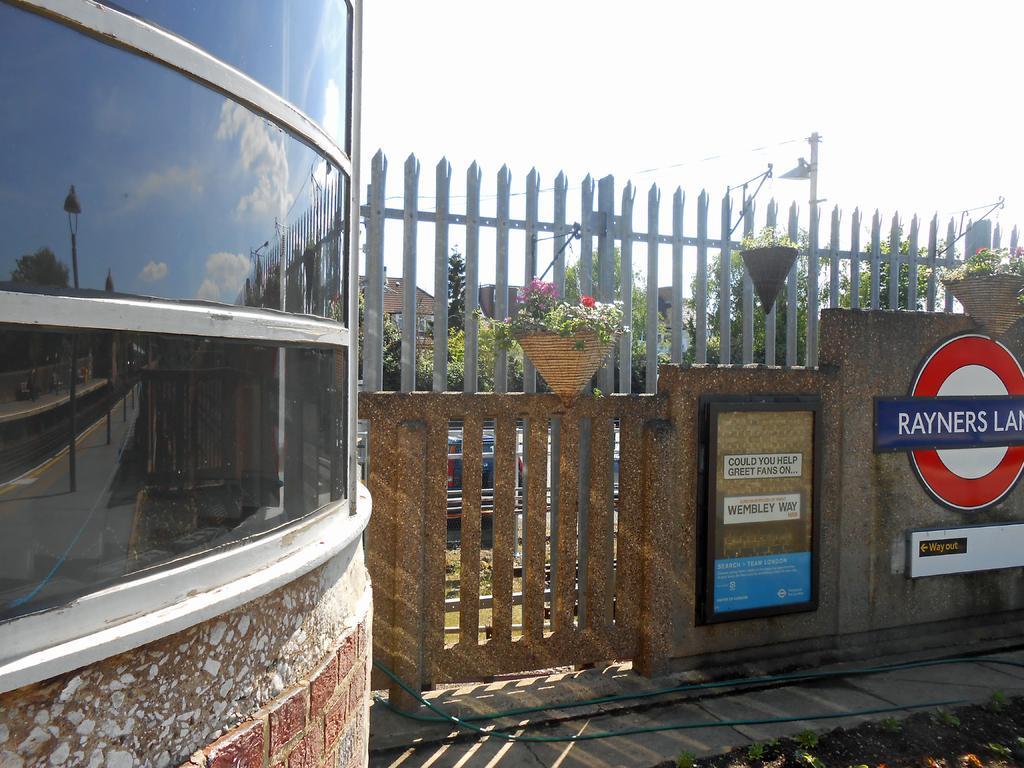In one or two sentences, can you explain what this image depicts? In this picture I can see buildings and a wall with couple boards on it with some text and few plants and trees and I can see a car parked and a pole and I can see a cloudy sky. 